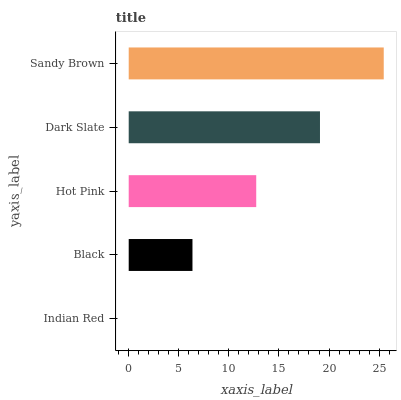Is Indian Red the minimum?
Answer yes or no. Yes. Is Sandy Brown the maximum?
Answer yes or no. Yes. Is Black the minimum?
Answer yes or no. No. Is Black the maximum?
Answer yes or no. No. Is Black greater than Indian Red?
Answer yes or no. Yes. Is Indian Red less than Black?
Answer yes or no. Yes. Is Indian Red greater than Black?
Answer yes or no. No. Is Black less than Indian Red?
Answer yes or no. No. Is Hot Pink the high median?
Answer yes or no. Yes. Is Hot Pink the low median?
Answer yes or no. Yes. Is Sandy Brown the high median?
Answer yes or no. No. Is Dark Slate the low median?
Answer yes or no. No. 